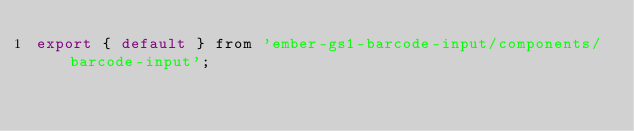<code> <loc_0><loc_0><loc_500><loc_500><_JavaScript_>export { default } from 'ember-gs1-barcode-input/components/barcode-input';
</code> 